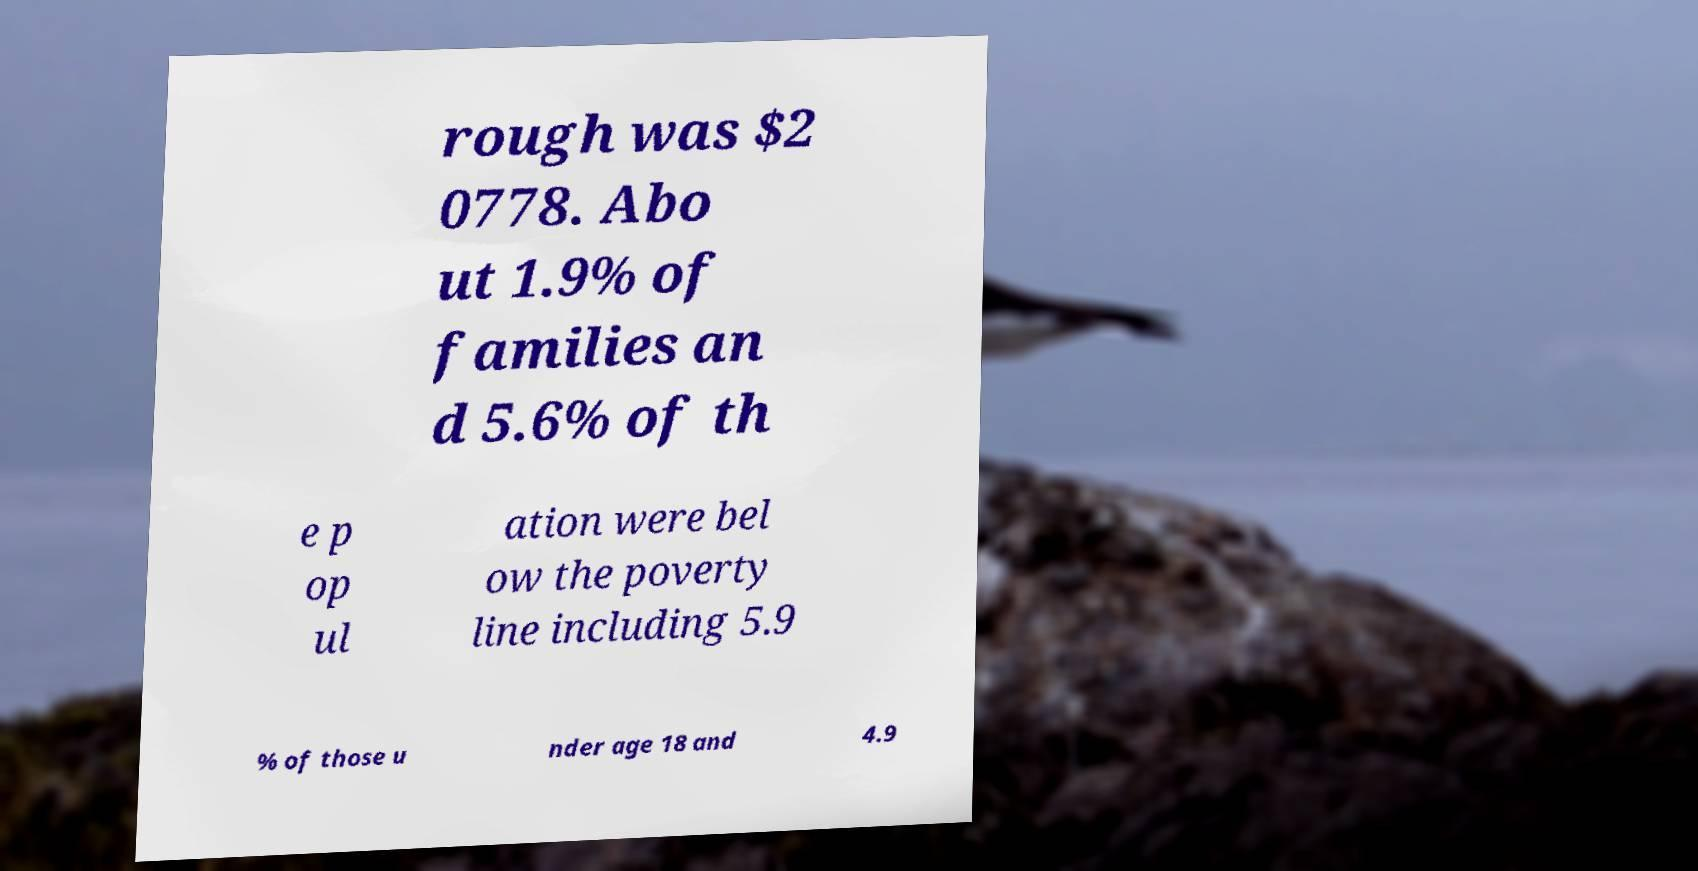Could you assist in decoding the text presented in this image and type it out clearly? rough was $2 0778. Abo ut 1.9% of families an d 5.6% of th e p op ul ation were bel ow the poverty line including 5.9 % of those u nder age 18 and 4.9 